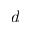<formula> <loc_0><loc_0><loc_500><loc_500>d</formula> 